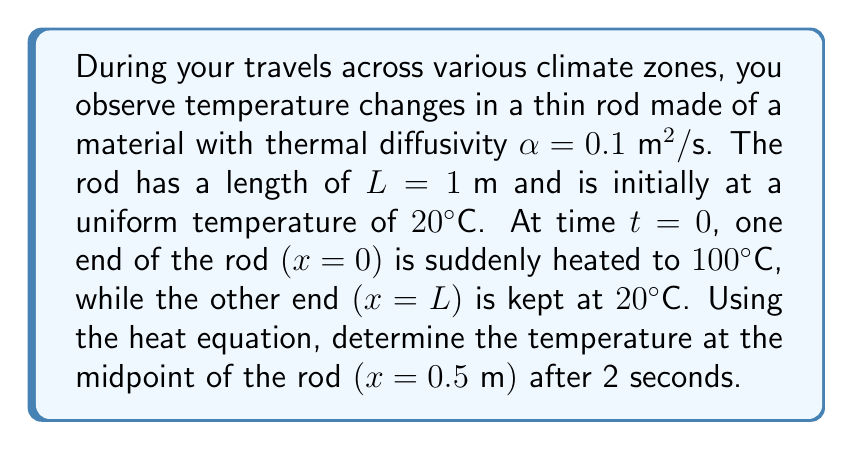Can you answer this question? To solve this problem, we'll use the heat equation and apply the given boundary conditions. Let's proceed step by step:

1) The heat equation in one dimension is:

   $$\frac{\partial u}{\partial t} = \alpha \frac{\partial^2 u}{\partial x^2}$$

   where $u(x,t)$ is the temperature at position $x$ and time $t$.

2) The initial and boundary conditions are:
   
   Initial condition: $u(x,0) = 20$ for $0 < x < L$
   Boundary conditions: $u(0,t) = 100$ and $u(L,t) = 20$ for $t > 0$

3) The solution to this problem can be expressed as:

   $$u(x,t) = 20 + 80\left(1 - \frac{x}{L}\right) + \frac{2}{\pi}\sum_{n=1}^{\infty}\frac{(-1)^{n+1}}{n}\sin\left(\frac{n\pi x}{L}\right)e^{-\alpha n^2\pi^2t/L^2}$$

4) We need to evaluate this at $x = 0.5 \text{ m}$ and $t = 2 \text{ s}$. Let's substitute the values:

   $L = 1 \text{ m}$, $\alpha = 0.1 \text{ m}^2/\text{s}$, $x = 0.5 \text{ m}$, $t = 2 \text{ s}$

5) Simplifying the non-series part:

   $20 + 80(1 - 0.5) = 60$

6) For the series part, we'll compute the first few terms:

   For $n = 1$: $\frac{2}{\pi} \cdot 1 \cdot \sin(\frac{\pi}{2}) \cdot e^{-0.1\pi^2 \cdot 2} \approx 0.2700$
   
   For $n = 2$: $\frac{2}{\pi} \cdot (-\frac{1}{2}) \cdot \sin(\pi) \cdot e^{-0.1(2\pi)^2 \cdot 2} \approx 0$
   
   For $n = 3$: $\frac{2}{\pi} \cdot \frac{1}{3} \cdot \sin(\frac{3\pi}{2}) \cdot e^{-0.1(3\pi)^2 \cdot 2} \approx -0.0003$

7) The series converges quickly, so we can approximate the solution using these terms:

   $u(0.5, 2) \approx 60 + 0.2700 + 0 - 0.0003 \approx 60.2697°\text{C}$
Answer: $60.27°\text{C}$ 